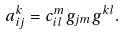Convert formula to latex. <formula><loc_0><loc_0><loc_500><loc_500>a _ { i j } ^ { k } = c _ { i l } ^ { m } g _ { j m } g ^ { k l } .</formula> 